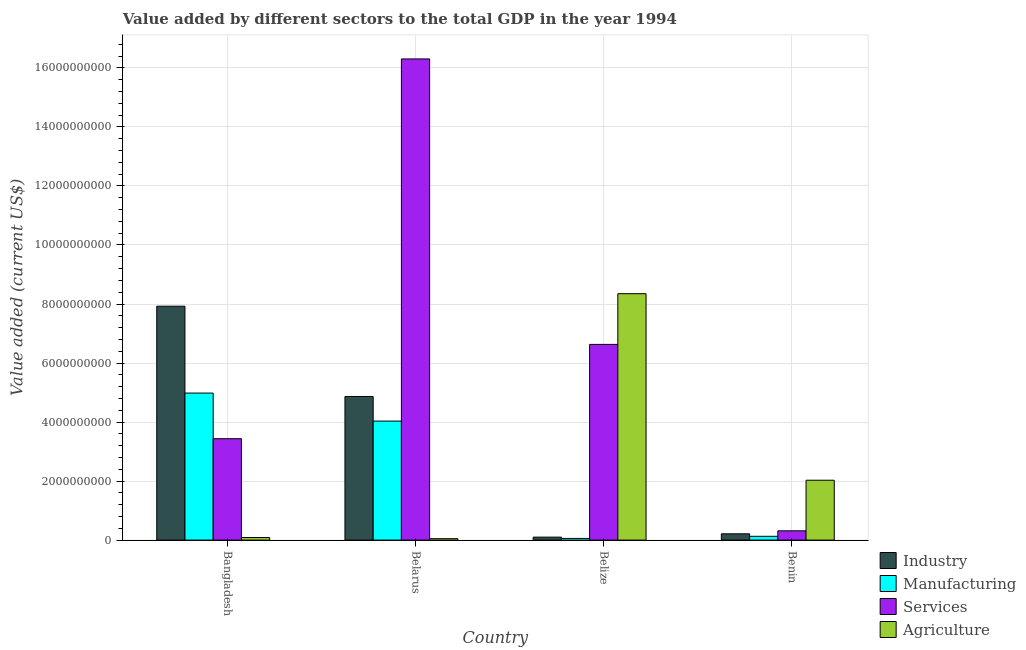How many different coloured bars are there?
Ensure brevity in your answer.  4. How many groups of bars are there?
Give a very brief answer. 4. Are the number of bars per tick equal to the number of legend labels?
Ensure brevity in your answer.  Yes. How many bars are there on the 2nd tick from the left?
Offer a very short reply. 4. How many bars are there on the 3rd tick from the right?
Make the answer very short. 4. What is the label of the 4th group of bars from the left?
Your response must be concise. Benin. What is the value added by industrial sector in Benin?
Offer a very short reply. 2.13e+08. Across all countries, what is the maximum value added by agricultural sector?
Ensure brevity in your answer.  8.35e+09. Across all countries, what is the minimum value added by industrial sector?
Make the answer very short. 1.01e+08. In which country was the value added by services sector maximum?
Provide a succinct answer. Belarus. In which country was the value added by industrial sector minimum?
Your answer should be compact. Belize. What is the total value added by manufacturing sector in the graph?
Offer a very short reply. 9.20e+09. What is the difference between the value added by agricultural sector in Bangladesh and that in Belize?
Your answer should be compact. -8.26e+09. What is the difference between the value added by agricultural sector in Bangladesh and the value added by industrial sector in Belize?
Give a very brief answer. -1.34e+07. What is the average value added by services sector per country?
Your answer should be compact. 6.67e+09. What is the difference between the value added by agricultural sector and value added by industrial sector in Benin?
Your answer should be very brief. 1.82e+09. What is the ratio of the value added by industrial sector in Bangladesh to that in Belize?
Provide a succinct answer. 78.78. Is the value added by industrial sector in Belarus less than that in Belize?
Offer a terse response. No. Is the difference between the value added by services sector in Bangladesh and Belize greater than the difference between the value added by industrial sector in Bangladesh and Belize?
Your answer should be very brief. No. What is the difference between the highest and the second highest value added by services sector?
Offer a terse response. 9.67e+09. What is the difference between the highest and the lowest value added by industrial sector?
Your answer should be compact. 7.82e+09. In how many countries, is the value added by services sector greater than the average value added by services sector taken over all countries?
Make the answer very short. 1. Is the sum of the value added by services sector in Bangladesh and Belarus greater than the maximum value added by manufacturing sector across all countries?
Provide a short and direct response. Yes. Is it the case that in every country, the sum of the value added by services sector and value added by industrial sector is greater than the sum of value added by manufacturing sector and value added by agricultural sector?
Offer a terse response. No. What does the 1st bar from the left in Belize represents?
Give a very brief answer. Industry. What does the 1st bar from the right in Belize represents?
Your answer should be compact. Agriculture. Is it the case that in every country, the sum of the value added by industrial sector and value added by manufacturing sector is greater than the value added by services sector?
Offer a very short reply. No. What is the difference between two consecutive major ticks on the Y-axis?
Offer a very short reply. 2.00e+09. Are the values on the major ticks of Y-axis written in scientific E-notation?
Your answer should be very brief. No. Where does the legend appear in the graph?
Your answer should be very brief. Bottom right. What is the title of the graph?
Make the answer very short. Value added by different sectors to the total GDP in the year 1994. What is the label or title of the X-axis?
Provide a short and direct response. Country. What is the label or title of the Y-axis?
Your answer should be compact. Value added (current US$). What is the Value added (current US$) in Industry in Bangladesh?
Offer a very short reply. 7.93e+09. What is the Value added (current US$) in Manufacturing in Bangladesh?
Give a very brief answer. 4.98e+09. What is the Value added (current US$) of Services in Bangladesh?
Provide a short and direct response. 3.44e+09. What is the Value added (current US$) in Agriculture in Bangladesh?
Make the answer very short. 8.72e+07. What is the Value added (current US$) of Industry in Belarus?
Provide a short and direct response. 4.87e+09. What is the Value added (current US$) of Manufacturing in Belarus?
Your response must be concise. 4.03e+09. What is the Value added (current US$) of Services in Belarus?
Make the answer very short. 1.63e+1. What is the Value added (current US$) in Agriculture in Belarus?
Make the answer very short. 4.79e+07. What is the Value added (current US$) in Industry in Belize?
Provide a short and direct response. 1.01e+08. What is the Value added (current US$) of Manufacturing in Belize?
Provide a short and direct response. 5.68e+07. What is the Value added (current US$) of Services in Belize?
Offer a terse response. 6.63e+09. What is the Value added (current US$) in Agriculture in Belize?
Your answer should be very brief. 8.35e+09. What is the Value added (current US$) of Industry in Benin?
Provide a succinct answer. 2.13e+08. What is the Value added (current US$) in Manufacturing in Benin?
Your answer should be very brief. 1.29e+08. What is the Value added (current US$) of Services in Benin?
Make the answer very short. 3.14e+08. What is the Value added (current US$) in Agriculture in Benin?
Keep it short and to the point. 2.03e+09. Across all countries, what is the maximum Value added (current US$) of Industry?
Ensure brevity in your answer.  7.93e+09. Across all countries, what is the maximum Value added (current US$) of Manufacturing?
Your answer should be compact. 4.98e+09. Across all countries, what is the maximum Value added (current US$) in Services?
Ensure brevity in your answer.  1.63e+1. Across all countries, what is the maximum Value added (current US$) in Agriculture?
Offer a very short reply. 8.35e+09. Across all countries, what is the minimum Value added (current US$) of Industry?
Your response must be concise. 1.01e+08. Across all countries, what is the minimum Value added (current US$) of Manufacturing?
Offer a very short reply. 5.68e+07. Across all countries, what is the minimum Value added (current US$) of Services?
Give a very brief answer. 3.14e+08. Across all countries, what is the minimum Value added (current US$) in Agriculture?
Your answer should be very brief. 4.79e+07. What is the total Value added (current US$) in Industry in the graph?
Ensure brevity in your answer.  1.31e+1. What is the total Value added (current US$) in Manufacturing in the graph?
Make the answer very short. 9.20e+09. What is the total Value added (current US$) in Services in the graph?
Your answer should be very brief. 2.67e+1. What is the total Value added (current US$) in Agriculture in the graph?
Give a very brief answer. 1.05e+1. What is the difference between the Value added (current US$) in Industry in Bangladesh and that in Belarus?
Your answer should be very brief. 3.06e+09. What is the difference between the Value added (current US$) in Manufacturing in Bangladesh and that in Belarus?
Your response must be concise. 9.49e+08. What is the difference between the Value added (current US$) of Services in Bangladesh and that in Belarus?
Your answer should be compact. -1.29e+1. What is the difference between the Value added (current US$) of Agriculture in Bangladesh and that in Belarus?
Your answer should be compact. 3.93e+07. What is the difference between the Value added (current US$) of Industry in Bangladesh and that in Belize?
Keep it short and to the point. 7.82e+09. What is the difference between the Value added (current US$) in Manufacturing in Bangladesh and that in Belize?
Your answer should be very brief. 4.93e+09. What is the difference between the Value added (current US$) in Services in Bangladesh and that in Belize?
Provide a short and direct response. -3.20e+09. What is the difference between the Value added (current US$) of Agriculture in Bangladesh and that in Belize?
Make the answer very short. -8.26e+09. What is the difference between the Value added (current US$) of Industry in Bangladesh and that in Benin?
Keep it short and to the point. 7.71e+09. What is the difference between the Value added (current US$) of Manufacturing in Bangladesh and that in Benin?
Your response must be concise. 4.85e+09. What is the difference between the Value added (current US$) of Services in Bangladesh and that in Benin?
Your response must be concise. 3.12e+09. What is the difference between the Value added (current US$) of Agriculture in Bangladesh and that in Benin?
Your answer should be compact. -1.94e+09. What is the difference between the Value added (current US$) in Industry in Belarus and that in Belize?
Your response must be concise. 4.77e+09. What is the difference between the Value added (current US$) in Manufacturing in Belarus and that in Belize?
Ensure brevity in your answer.  3.98e+09. What is the difference between the Value added (current US$) in Services in Belarus and that in Belize?
Offer a terse response. 9.67e+09. What is the difference between the Value added (current US$) of Agriculture in Belarus and that in Belize?
Offer a terse response. -8.30e+09. What is the difference between the Value added (current US$) of Industry in Belarus and that in Benin?
Give a very brief answer. 4.65e+09. What is the difference between the Value added (current US$) in Manufacturing in Belarus and that in Benin?
Provide a succinct answer. 3.90e+09. What is the difference between the Value added (current US$) in Services in Belarus and that in Benin?
Your answer should be very brief. 1.60e+1. What is the difference between the Value added (current US$) in Agriculture in Belarus and that in Benin?
Offer a terse response. -1.98e+09. What is the difference between the Value added (current US$) in Industry in Belize and that in Benin?
Your answer should be compact. -1.13e+08. What is the difference between the Value added (current US$) of Manufacturing in Belize and that in Benin?
Provide a succinct answer. -7.19e+07. What is the difference between the Value added (current US$) of Services in Belize and that in Benin?
Provide a short and direct response. 6.32e+09. What is the difference between the Value added (current US$) of Agriculture in Belize and that in Benin?
Offer a very short reply. 6.32e+09. What is the difference between the Value added (current US$) in Industry in Bangladesh and the Value added (current US$) in Manufacturing in Belarus?
Your response must be concise. 3.89e+09. What is the difference between the Value added (current US$) of Industry in Bangladesh and the Value added (current US$) of Services in Belarus?
Keep it short and to the point. -8.38e+09. What is the difference between the Value added (current US$) in Industry in Bangladesh and the Value added (current US$) in Agriculture in Belarus?
Your answer should be very brief. 7.88e+09. What is the difference between the Value added (current US$) in Manufacturing in Bangladesh and the Value added (current US$) in Services in Belarus?
Ensure brevity in your answer.  -1.13e+1. What is the difference between the Value added (current US$) of Manufacturing in Bangladesh and the Value added (current US$) of Agriculture in Belarus?
Provide a short and direct response. 4.93e+09. What is the difference between the Value added (current US$) in Services in Bangladesh and the Value added (current US$) in Agriculture in Belarus?
Keep it short and to the point. 3.39e+09. What is the difference between the Value added (current US$) of Industry in Bangladesh and the Value added (current US$) of Manufacturing in Belize?
Ensure brevity in your answer.  7.87e+09. What is the difference between the Value added (current US$) in Industry in Bangladesh and the Value added (current US$) in Services in Belize?
Ensure brevity in your answer.  1.29e+09. What is the difference between the Value added (current US$) in Industry in Bangladesh and the Value added (current US$) in Agriculture in Belize?
Ensure brevity in your answer.  -4.24e+08. What is the difference between the Value added (current US$) of Manufacturing in Bangladesh and the Value added (current US$) of Services in Belize?
Offer a terse response. -1.65e+09. What is the difference between the Value added (current US$) in Manufacturing in Bangladesh and the Value added (current US$) in Agriculture in Belize?
Your response must be concise. -3.37e+09. What is the difference between the Value added (current US$) of Services in Bangladesh and the Value added (current US$) of Agriculture in Belize?
Provide a succinct answer. -4.91e+09. What is the difference between the Value added (current US$) in Industry in Bangladesh and the Value added (current US$) in Manufacturing in Benin?
Keep it short and to the point. 7.80e+09. What is the difference between the Value added (current US$) in Industry in Bangladesh and the Value added (current US$) in Services in Benin?
Provide a short and direct response. 7.61e+09. What is the difference between the Value added (current US$) of Industry in Bangladesh and the Value added (current US$) of Agriculture in Benin?
Ensure brevity in your answer.  5.90e+09. What is the difference between the Value added (current US$) of Manufacturing in Bangladesh and the Value added (current US$) of Services in Benin?
Offer a very short reply. 4.67e+09. What is the difference between the Value added (current US$) in Manufacturing in Bangladesh and the Value added (current US$) in Agriculture in Benin?
Your answer should be compact. 2.95e+09. What is the difference between the Value added (current US$) in Services in Bangladesh and the Value added (current US$) in Agriculture in Benin?
Give a very brief answer. 1.41e+09. What is the difference between the Value added (current US$) in Industry in Belarus and the Value added (current US$) in Manufacturing in Belize?
Give a very brief answer. 4.81e+09. What is the difference between the Value added (current US$) in Industry in Belarus and the Value added (current US$) in Services in Belize?
Give a very brief answer. -1.76e+09. What is the difference between the Value added (current US$) of Industry in Belarus and the Value added (current US$) of Agriculture in Belize?
Provide a succinct answer. -3.48e+09. What is the difference between the Value added (current US$) of Manufacturing in Belarus and the Value added (current US$) of Services in Belize?
Your answer should be very brief. -2.60e+09. What is the difference between the Value added (current US$) in Manufacturing in Belarus and the Value added (current US$) in Agriculture in Belize?
Your answer should be very brief. -4.32e+09. What is the difference between the Value added (current US$) of Services in Belarus and the Value added (current US$) of Agriculture in Belize?
Offer a terse response. 7.95e+09. What is the difference between the Value added (current US$) of Industry in Belarus and the Value added (current US$) of Manufacturing in Benin?
Offer a terse response. 4.74e+09. What is the difference between the Value added (current US$) in Industry in Belarus and the Value added (current US$) in Services in Benin?
Provide a succinct answer. 4.55e+09. What is the difference between the Value added (current US$) in Industry in Belarus and the Value added (current US$) in Agriculture in Benin?
Provide a short and direct response. 2.84e+09. What is the difference between the Value added (current US$) in Manufacturing in Belarus and the Value added (current US$) in Services in Benin?
Keep it short and to the point. 3.72e+09. What is the difference between the Value added (current US$) in Manufacturing in Belarus and the Value added (current US$) in Agriculture in Benin?
Provide a short and direct response. 2.00e+09. What is the difference between the Value added (current US$) of Services in Belarus and the Value added (current US$) of Agriculture in Benin?
Offer a very short reply. 1.43e+1. What is the difference between the Value added (current US$) of Industry in Belize and the Value added (current US$) of Manufacturing in Benin?
Ensure brevity in your answer.  -2.81e+07. What is the difference between the Value added (current US$) in Industry in Belize and the Value added (current US$) in Services in Benin?
Keep it short and to the point. -2.14e+08. What is the difference between the Value added (current US$) in Industry in Belize and the Value added (current US$) in Agriculture in Benin?
Ensure brevity in your answer.  -1.93e+09. What is the difference between the Value added (current US$) in Manufacturing in Belize and the Value added (current US$) in Services in Benin?
Your response must be concise. -2.58e+08. What is the difference between the Value added (current US$) of Manufacturing in Belize and the Value added (current US$) of Agriculture in Benin?
Keep it short and to the point. -1.97e+09. What is the difference between the Value added (current US$) in Services in Belize and the Value added (current US$) in Agriculture in Benin?
Ensure brevity in your answer.  4.60e+09. What is the average Value added (current US$) in Industry per country?
Provide a short and direct response. 3.28e+09. What is the average Value added (current US$) in Manufacturing per country?
Offer a very short reply. 2.30e+09. What is the average Value added (current US$) of Services per country?
Your response must be concise. 6.67e+09. What is the average Value added (current US$) of Agriculture per country?
Offer a very short reply. 2.63e+09. What is the difference between the Value added (current US$) of Industry and Value added (current US$) of Manufacturing in Bangladesh?
Keep it short and to the point. 2.94e+09. What is the difference between the Value added (current US$) in Industry and Value added (current US$) in Services in Bangladesh?
Give a very brief answer. 4.49e+09. What is the difference between the Value added (current US$) in Industry and Value added (current US$) in Agriculture in Bangladesh?
Offer a very short reply. 7.84e+09. What is the difference between the Value added (current US$) of Manufacturing and Value added (current US$) of Services in Bangladesh?
Provide a short and direct response. 1.55e+09. What is the difference between the Value added (current US$) in Manufacturing and Value added (current US$) in Agriculture in Bangladesh?
Keep it short and to the point. 4.90e+09. What is the difference between the Value added (current US$) in Services and Value added (current US$) in Agriculture in Bangladesh?
Give a very brief answer. 3.35e+09. What is the difference between the Value added (current US$) in Industry and Value added (current US$) in Manufacturing in Belarus?
Your answer should be very brief. 8.33e+08. What is the difference between the Value added (current US$) in Industry and Value added (current US$) in Services in Belarus?
Offer a very short reply. -1.14e+1. What is the difference between the Value added (current US$) of Industry and Value added (current US$) of Agriculture in Belarus?
Your answer should be compact. 4.82e+09. What is the difference between the Value added (current US$) of Manufacturing and Value added (current US$) of Services in Belarus?
Your answer should be very brief. -1.23e+1. What is the difference between the Value added (current US$) in Manufacturing and Value added (current US$) in Agriculture in Belarus?
Your answer should be compact. 3.99e+09. What is the difference between the Value added (current US$) of Services and Value added (current US$) of Agriculture in Belarus?
Offer a very short reply. 1.63e+1. What is the difference between the Value added (current US$) in Industry and Value added (current US$) in Manufacturing in Belize?
Make the answer very short. 4.38e+07. What is the difference between the Value added (current US$) in Industry and Value added (current US$) in Services in Belize?
Offer a very short reply. -6.53e+09. What is the difference between the Value added (current US$) of Industry and Value added (current US$) of Agriculture in Belize?
Offer a very short reply. -8.25e+09. What is the difference between the Value added (current US$) in Manufacturing and Value added (current US$) in Services in Belize?
Your response must be concise. -6.57e+09. What is the difference between the Value added (current US$) in Manufacturing and Value added (current US$) in Agriculture in Belize?
Your response must be concise. -8.29e+09. What is the difference between the Value added (current US$) in Services and Value added (current US$) in Agriculture in Belize?
Offer a terse response. -1.72e+09. What is the difference between the Value added (current US$) in Industry and Value added (current US$) in Manufacturing in Benin?
Your response must be concise. 8.44e+07. What is the difference between the Value added (current US$) of Industry and Value added (current US$) of Services in Benin?
Provide a short and direct response. -1.01e+08. What is the difference between the Value added (current US$) in Industry and Value added (current US$) in Agriculture in Benin?
Provide a short and direct response. -1.82e+09. What is the difference between the Value added (current US$) in Manufacturing and Value added (current US$) in Services in Benin?
Make the answer very short. -1.86e+08. What is the difference between the Value added (current US$) in Manufacturing and Value added (current US$) in Agriculture in Benin?
Give a very brief answer. -1.90e+09. What is the difference between the Value added (current US$) in Services and Value added (current US$) in Agriculture in Benin?
Your answer should be compact. -1.71e+09. What is the ratio of the Value added (current US$) in Industry in Bangladesh to that in Belarus?
Give a very brief answer. 1.63. What is the ratio of the Value added (current US$) of Manufacturing in Bangladesh to that in Belarus?
Make the answer very short. 1.24. What is the ratio of the Value added (current US$) in Services in Bangladesh to that in Belarus?
Make the answer very short. 0.21. What is the ratio of the Value added (current US$) in Agriculture in Bangladesh to that in Belarus?
Ensure brevity in your answer.  1.82. What is the ratio of the Value added (current US$) of Industry in Bangladesh to that in Belize?
Provide a short and direct response. 78.78. What is the ratio of the Value added (current US$) in Manufacturing in Bangladesh to that in Belize?
Provide a succinct answer. 87.75. What is the ratio of the Value added (current US$) of Services in Bangladesh to that in Belize?
Provide a succinct answer. 0.52. What is the ratio of the Value added (current US$) in Agriculture in Bangladesh to that in Belize?
Make the answer very short. 0.01. What is the ratio of the Value added (current US$) of Industry in Bangladesh to that in Benin?
Make the answer very short. 37.18. What is the ratio of the Value added (current US$) of Manufacturing in Bangladesh to that in Benin?
Offer a very short reply. 38.71. What is the ratio of the Value added (current US$) in Services in Bangladesh to that in Benin?
Your response must be concise. 10.93. What is the ratio of the Value added (current US$) of Agriculture in Bangladesh to that in Benin?
Give a very brief answer. 0.04. What is the ratio of the Value added (current US$) in Industry in Belarus to that in Belize?
Provide a succinct answer. 48.37. What is the ratio of the Value added (current US$) of Manufacturing in Belarus to that in Belize?
Give a very brief answer. 71.04. What is the ratio of the Value added (current US$) of Services in Belarus to that in Belize?
Your response must be concise. 2.46. What is the ratio of the Value added (current US$) in Agriculture in Belarus to that in Belize?
Provide a short and direct response. 0.01. What is the ratio of the Value added (current US$) in Industry in Belarus to that in Benin?
Your answer should be very brief. 22.83. What is the ratio of the Value added (current US$) in Manufacturing in Belarus to that in Benin?
Offer a very short reply. 31.34. What is the ratio of the Value added (current US$) of Services in Belarus to that in Benin?
Give a very brief answer. 51.85. What is the ratio of the Value added (current US$) of Agriculture in Belarus to that in Benin?
Your response must be concise. 0.02. What is the ratio of the Value added (current US$) of Industry in Belize to that in Benin?
Offer a terse response. 0.47. What is the ratio of the Value added (current US$) of Manufacturing in Belize to that in Benin?
Your answer should be very brief. 0.44. What is the ratio of the Value added (current US$) of Services in Belize to that in Benin?
Ensure brevity in your answer.  21.09. What is the ratio of the Value added (current US$) in Agriculture in Belize to that in Benin?
Provide a succinct answer. 4.12. What is the difference between the highest and the second highest Value added (current US$) of Industry?
Your response must be concise. 3.06e+09. What is the difference between the highest and the second highest Value added (current US$) in Manufacturing?
Ensure brevity in your answer.  9.49e+08. What is the difference between the highest and the second highest Value added (current US$) in Services?
Provide a short and direct response. 9.67e+09. What is the difference between the highest and the second highest Value added (current US$) in Agriculture?
Give a very brief answer. 6.32e+09. What is the difference between the highest and the lowest Value added (current US$) in Industry?
Ensure brevity in your answer.  7.82e+09. What is the difference between the highest and the lowest Value added (current US$) in Manufacturing?
Offer a very short reply. 4.93e+09. What is the difference between the highest and the lowest Value added (current US$) in Services?
Your response must be concise. 1.60e+1. What is the difference between the highest and the lowest Value added (current US$) in Agriculture?
Provide a short and direct response. 8.30e+09. 